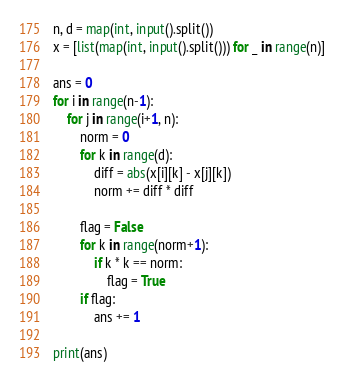<code> <loc_0><loc_0><loc_500><loc_500><_Python_>n, d = map(int, input().split())
x = [list(map(int, input().split())) for _ in range(n)]

ans = 0
for i in range(n-1):
    for j in range(i+1, n):
        norm = 0
        for k in range(d):
            diff = abs(x[i][k] - x[j][k])
            norm += diff * diff
    
        flag = False
        for k in range(norm+1):
            if k * k == norm:
                flag = True
        if flag:
            ans += 1

print(ans)</code> 